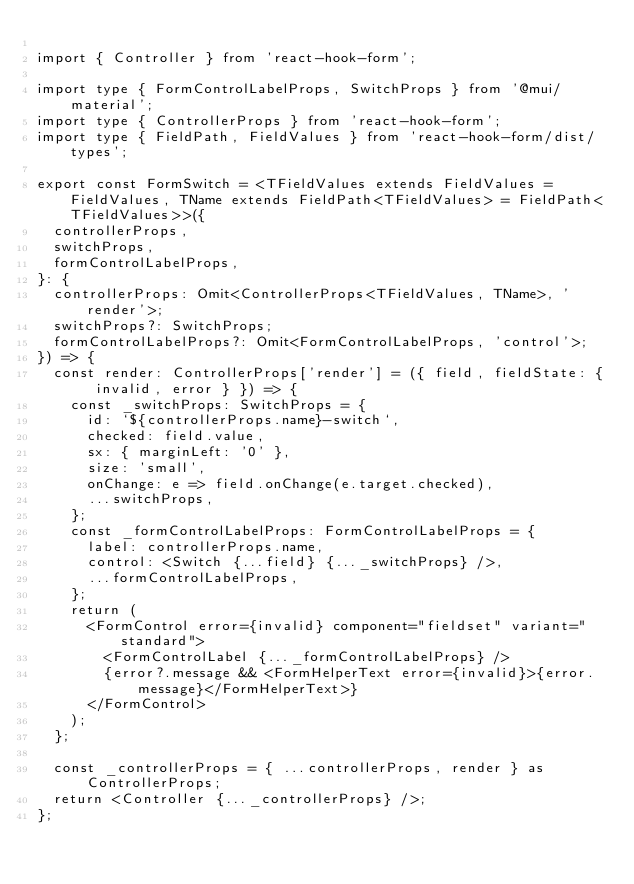<code> <loc_0><loc_0><loc_500><loc_500><_TypeScript_>
import { Controller } from 'react-hook-form';

import type { FormControlLabelProps, SwitchProps } from '@mui/material';
import type { ControllerProps } from 'react-hook-form';
import type { FieldPath, FieldValues } from 'react-hook-form/dist/types';

export const FormSwitch = <TFieldValues extends FieldValues = FieldValues, TName extends FieldPath<TFieldValues> = FieldPath<TFieldValues>>({
  controllerProps,
  switchProps,
  formControlLabelProps,
}: {
  controllerProps: Omit<ControllerProps<TFieldValues, TName>, 'render'>;
  switchProps?: SwitchProps;
  formControlLabelProps?: Omit<FormControlLabelProps, 'control'>;
}) => {
  const render: ControllerProps['render'] = ({ field, fieldState: { invalid, error } }) => {
    const _switchProps: SwitchProps = {
      id: `${controllerProps.name}-switch`,
      checked: field.value,
      sx: { marginLeft: '0' },
      size: 'small',
      onChange: e => field.onChange(e.target.checked),
      ...switchProps,
    };
    const _formControlLabelProps: FormControlLabelProps = {
      label: controllerProps.name,
      control: <Switch {...field} {..._switchProps} />,
      ...formControlLabelProps,
    };
    return (
      <FormControl error={invalid} component="fieldset" variant="standard">
        <FormControlLabel {..._formControlLabelProps} />
        {error?.message && <FormHelperText error={invalid}>{error.message}</FormHelperText>}
      </FormControl>
    );
  };

  const _controllerProps = { ...controllerProps, render } as ControllerProps;
  return <Controller {..._controllerProps} />;
};
</code> 